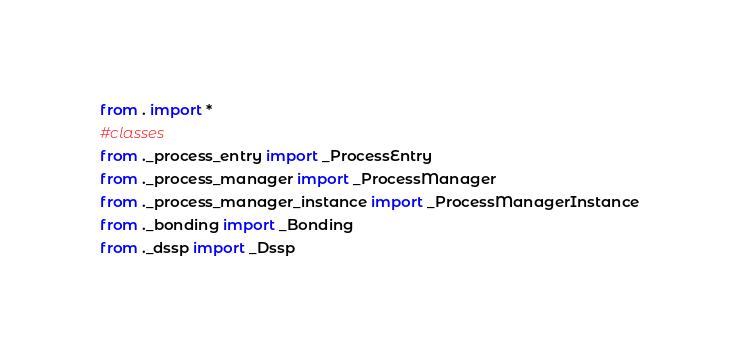Convert code to text. <code><loc_0><loc_0><loc_500><loc_500><_Python_>from . import *
#classes
from ._process_entry import _ProcessEntry
from ._process_manager import _ProcessManager
from ._process_manager_instance import _ProcessManagerInstance
from ._bonding import _Bonding
from ._dssp import _Dssp</code> 